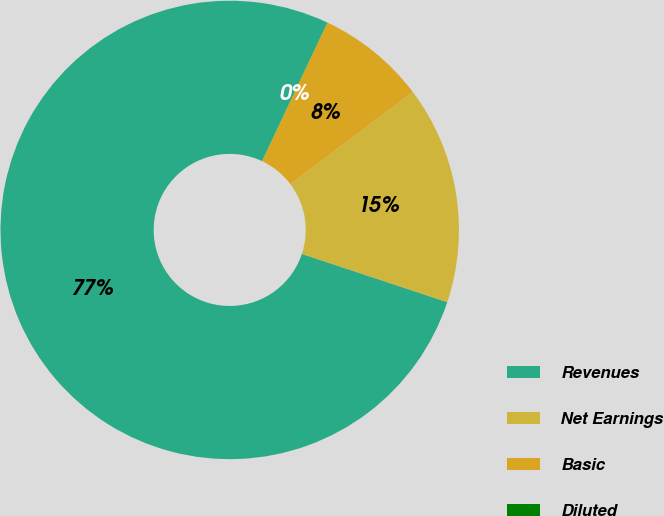Convert chart to OTSL. <chart><loc_0><loc_0><loc_500><loc_500><pie_chart><fcel>Revenues<fcel>Net Earnings<fcel>Basic<fcel>Diluted<nl><fcel>76.91%<fcel>15.39%<fcel>7.7%<fcel>0.01%<nl></chart> 